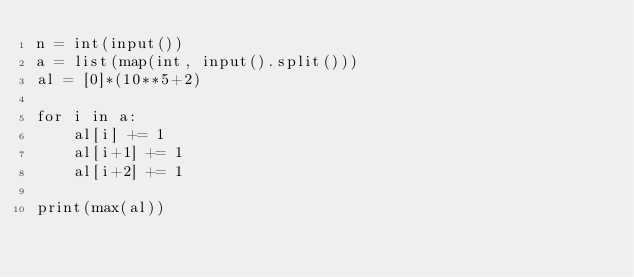Convert code to text. <code><loc_0><loc_0><loc_500><loc_500><_Python_>n = int(input())
a = list(map(int, input().split()))
al = [0]*(10**5+2)

for i in a:
    al[i] += 1
    al[i+1] += 1
    al[i+2] += 1

print(max(al))</code> 